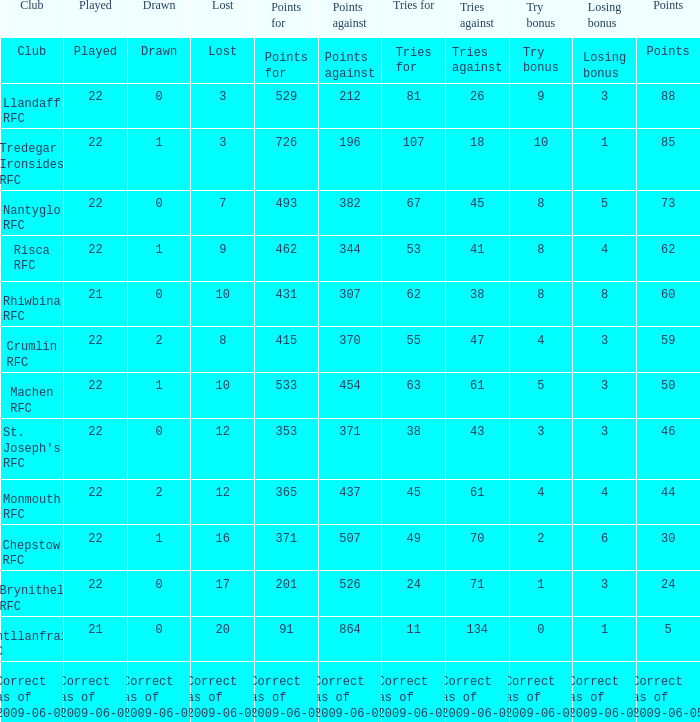If the played was executed, what is the disappeared? Lost. 